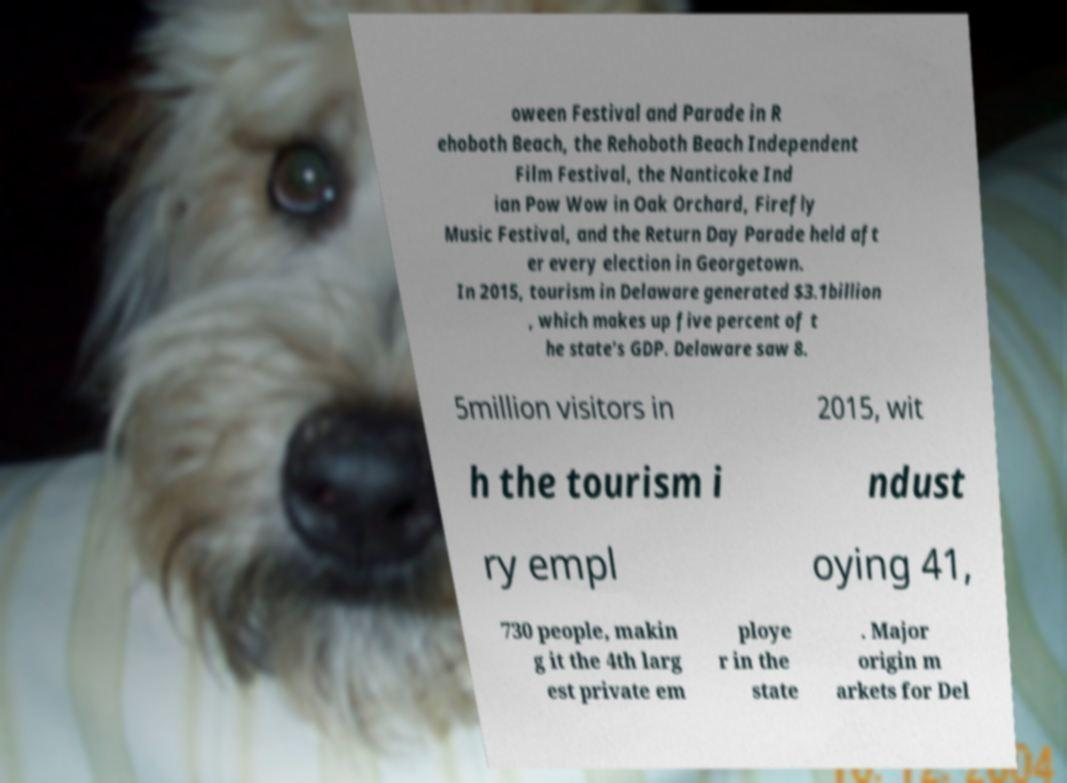Please identify and transcribe the text found in this image. oween Festival and Parade in R ehoboth Beach, the Rehoboth Beach Independent Film Festival, the Nanticoke Ind ian Pow Wow in Oak Orchard, Firefly Music Festival, and the Return Day Parade held aft er every election in Georgetown. In 2015, tourism in Delaware generated $3.1billion , which makes up five percent of t he state's GDP. Delaware saw 8. 5million visitors in 2015, wit h the tourism i ndust ry empl oying 41, 730 people, makin g it the 4th larg est private em ploye r in the state . Major origin m arkets for Del 